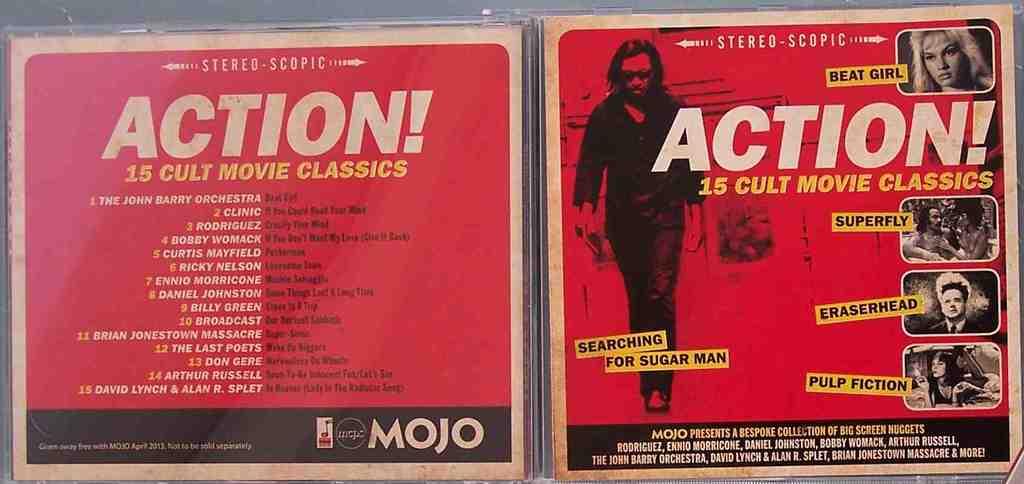What is the action movie on the right ?
Your answer should be compact. Beat girl. 